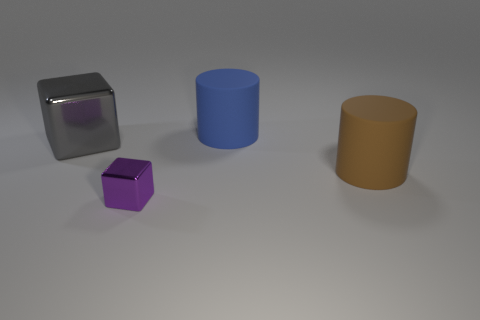Add 3 large shiny things. How many objects exist? 7 Subtract all brown cylinders. Subtract all big shiny things. How many objects are left? 2 Add 1 metal objects. How many metal objects are left? 3 Add 2 big matte cylinders. How many big matte cylinders exist? 4 Subtract 0 green cylinders. How many objects are left? 4 